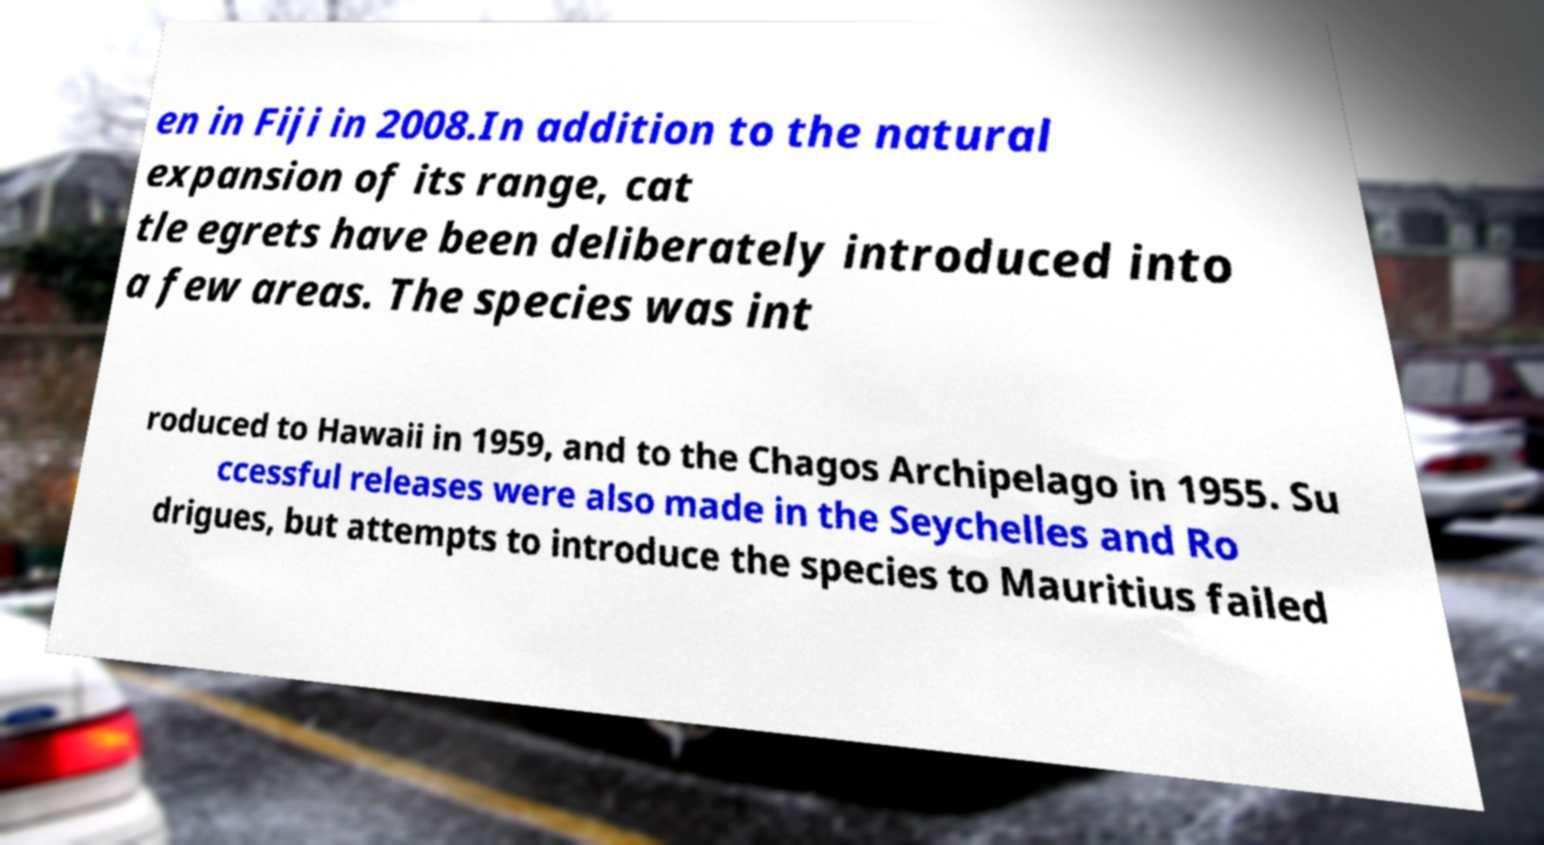Please identify and transcribe the text found in this image. en in Fiji in 2008.In addition to the natural expansion of its range, cat tle egrets have been deliberately introduced into a few areas. The species was int roduced to Hawaii in 1959, and to the Chagos Archipelago in 1955. Su ccessful releases were also made in the Seychelles and Ro drigues, but attempts to introduce the species to Mauritius failed 